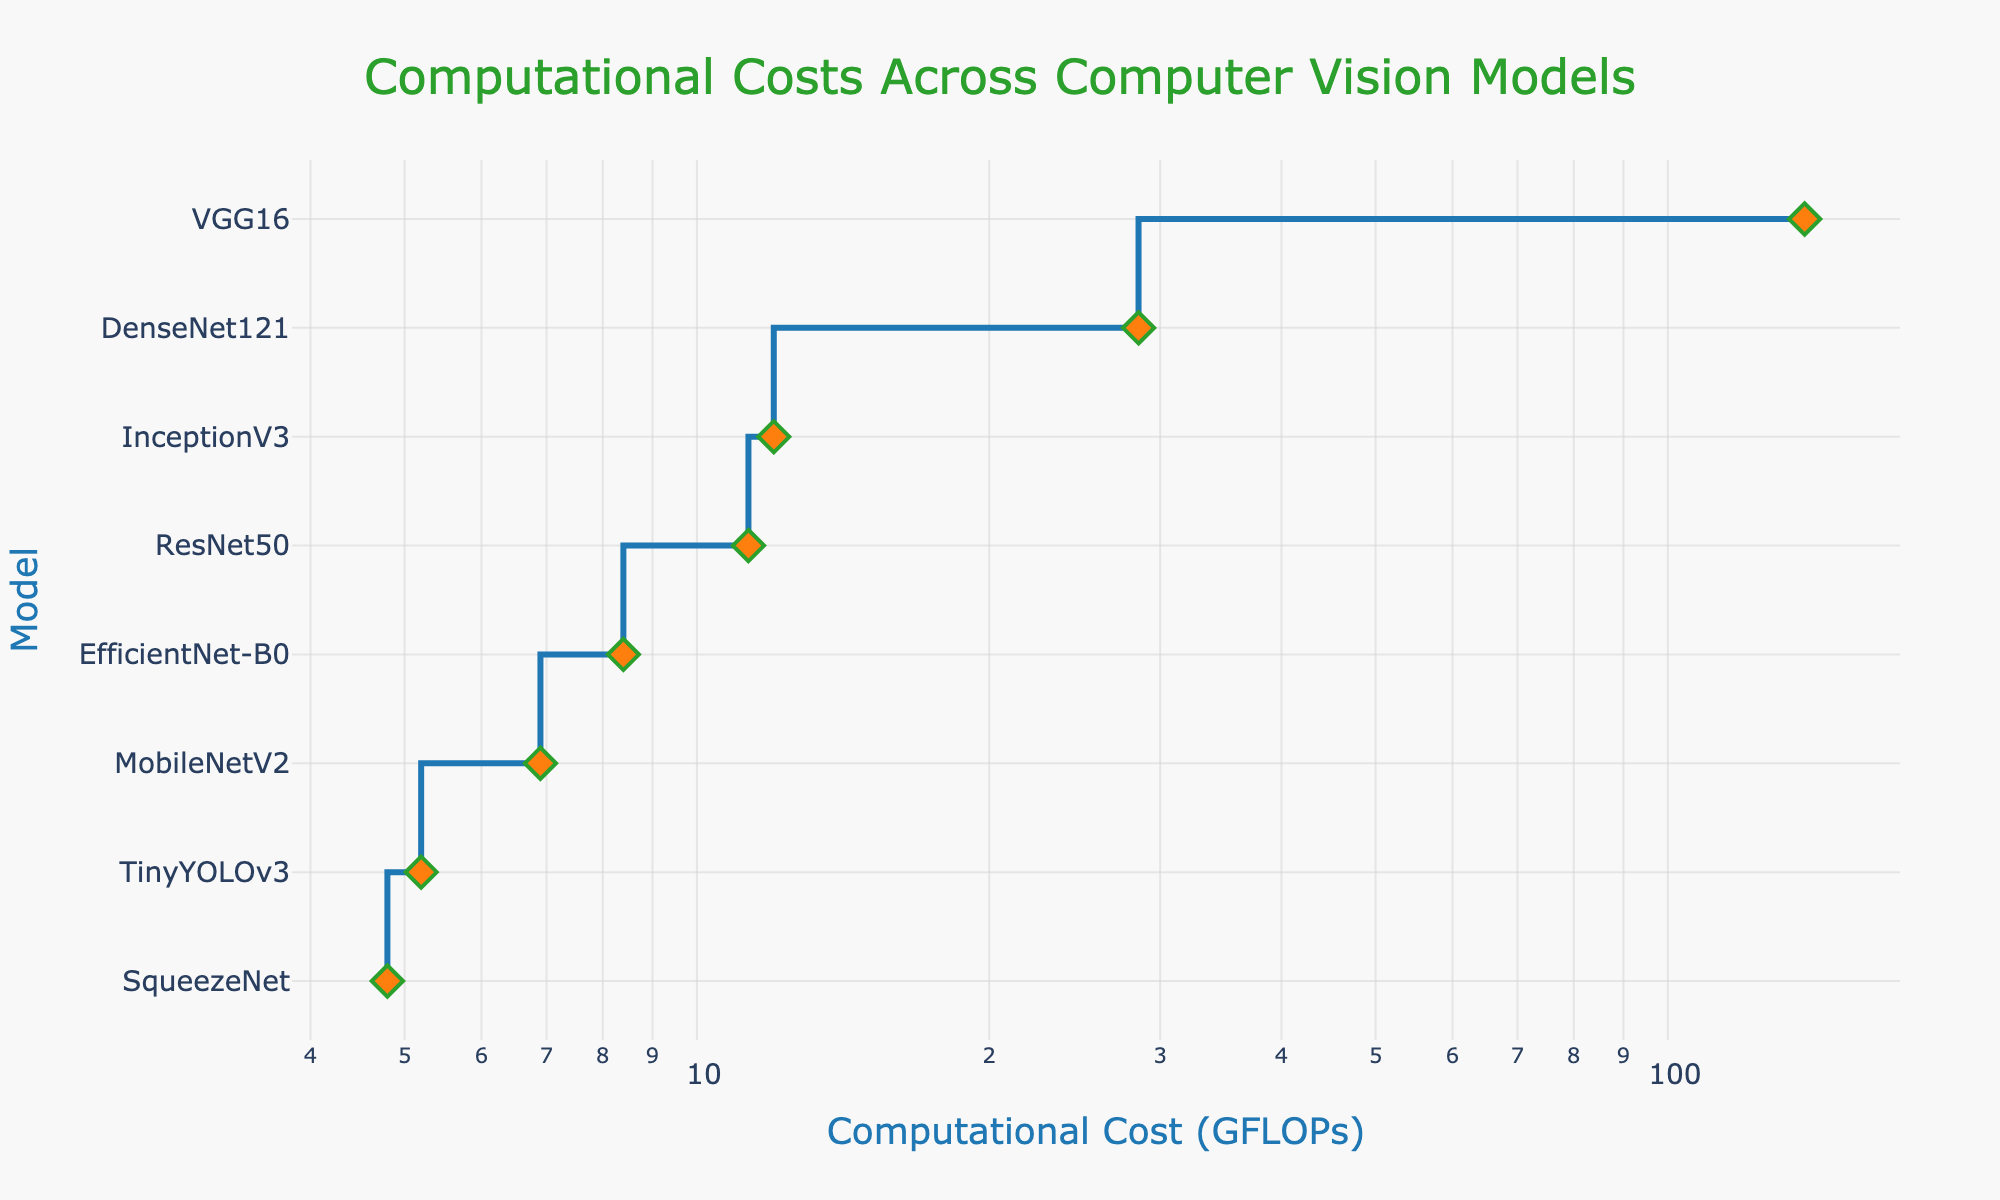Which model has the lowest computational cost? The figure shows a stair plot of the computational costs of different models. The model at the lowest point on the y-axis has the smallest computational cost.
Answer: SqueezeNet Which model has the highest computational cost? The model at the highest point on the y-axis represents the one with the highest computational cost on the plot.
Answer: VGG16 How many models have computational costs less than 10 GFLOPs? From the plot, identify and count all models that fall to the left of the 10 GFLOPs mark on the x-axis.
Answer: 4 Which two models have computational costs closest to each other? By inspecting the stair plot, find the two adjacent points on the x-axis with the smallest interval.
Answer: TinyYOLOv3 and MobileNetV2 What is the range of computational costs for all the models? Calculate the difference between the highest computational cost (max) and the lowest computational cost (min) shown on the plot.
Answer: 138.3 - 4.8 = 133.5 GFLOPs Which model has the second highest computational cost? Identify the second-highest point on the y-axis in the stair plot and note the corresponding model.
Answer: DenseNet121 How does EfficientNet-B0's computational cost compare to InceptionV3? Locate the positions of both models on the x-axis and compare their values (EfficientNet-B0 is closer to the origin than InceptionV3).
Answer: EfficientNet-B0 has a lower computational cost What's the average computational cost of TinyYOLOv3, MobileNetV2, and SqueezeNet? Add the computational costs of the three models and divide by the number of models: (5.2 + 6.9 + 4.8) / 3.
Answer: 5.63 GFLOPs If we removed VGG16 from the analysis, what would be the new highest computational cost? Ignore VGG16 and identify the next highest point on the x-axis in the stair plot.
Answer: DenseNet121 